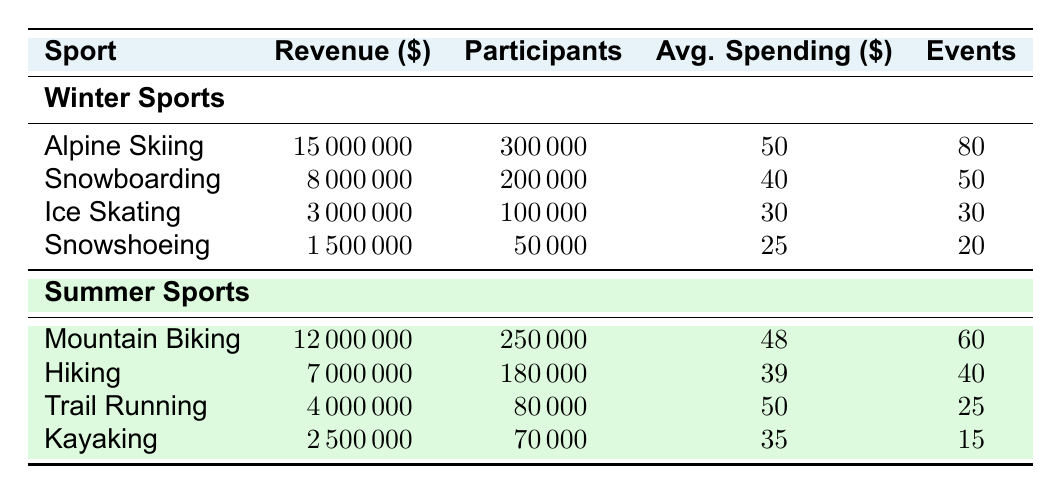What is the total revenue generated from winter sports? To find the total revenue from winter sports, I will sum the revenues of all the winter sports listed: 15,000,000 (Alpine Skiing) + 8,000,000 (Snowboarding) + 3,000,000 (Ice Skating) + 1,500,000 (Snowshoeing) = 27,500,000.
Answer: 27,500,000 Which winter sport had the highest average spending per participant? Comparing the average spending per participant for each winter sport: Alpine Skiing is 50, Snowboarding is 40, Ice Skating is 30, and Snowshoeing is 25. The highest value is 50, which corresponds to Alpine Skiing.
Answer: Alpine Skiing How many participants were there in total for summer sports? I will sum the participants from all summer sports: 250,000 (Mountain Biking) + 180,000 (Hiking) + 80,000 (Trail Running) + 70,000 (Kayaking) = 580,000 participants.
Answer: 580,000 Did snowshoeing generate more revenue than kayaking? The revenue for snowshoeing is 1,500,000, and for kayaking, it is 2,500,000. Since 1,500,000 is less than 2,500,000, the answer is no.
Answer: No What is the average revenue per event for alpine skiing? The revenue for alpine skiing is 15,000,000, and there are 80 events. Average revenue per event is calculated as 15,000,000 / 80 = 187,500.
Answer: 187,500 Which summer sport had the least number of participants? Comparing the number of participants for summer sports: Mountain Biking has 250,000, Hiking has 180,000, Trail Running has 80,000, and Kayaking has 70,000. The least number is 70,000 from Kayaking.
Answer: Kayaking What is the difference in revenue between the highest and lowest generating sports from winter sports? The highest revenue in winter sports comes from Alpine Skiing at 15,000,000, and the lowest from Snowshoeing at 1,500,000. The difference is 15,000,000 - 1,500,000 = 13,500,000.
Answer: 13,500,000 Which group (winter or summer sports) generated more total revenue? Total revenue for winter sports is 27,500,000, and for summer sports, it is 12,000,000 + 7,000,000 + 4,000,000 + 2,500,000 = 25,500,000. Since 27,500,000 is greater than 25,500,000, winter sports generated more.
Answer: Winter sports How many events were held in total for snowboarding and mountain biking combined? The number of events for snowboarding is 50, and for mountain biking is 60. Adding them together gives 50 + 60 = 110 events combined.
Answer: 110 Is the average spending per participant higher for summer sports overall compared to winter sports? I will calculate the average spending for winter sports: (50 + 40 + 30 + 25) / 4 = 36.25, and for summer sports: (48 + 39 + 50 + 35) / 4 = 43. Thereby, comparing 43 (summer) with 36.25 (winter), summer has a higher average.
Answer: Yes 